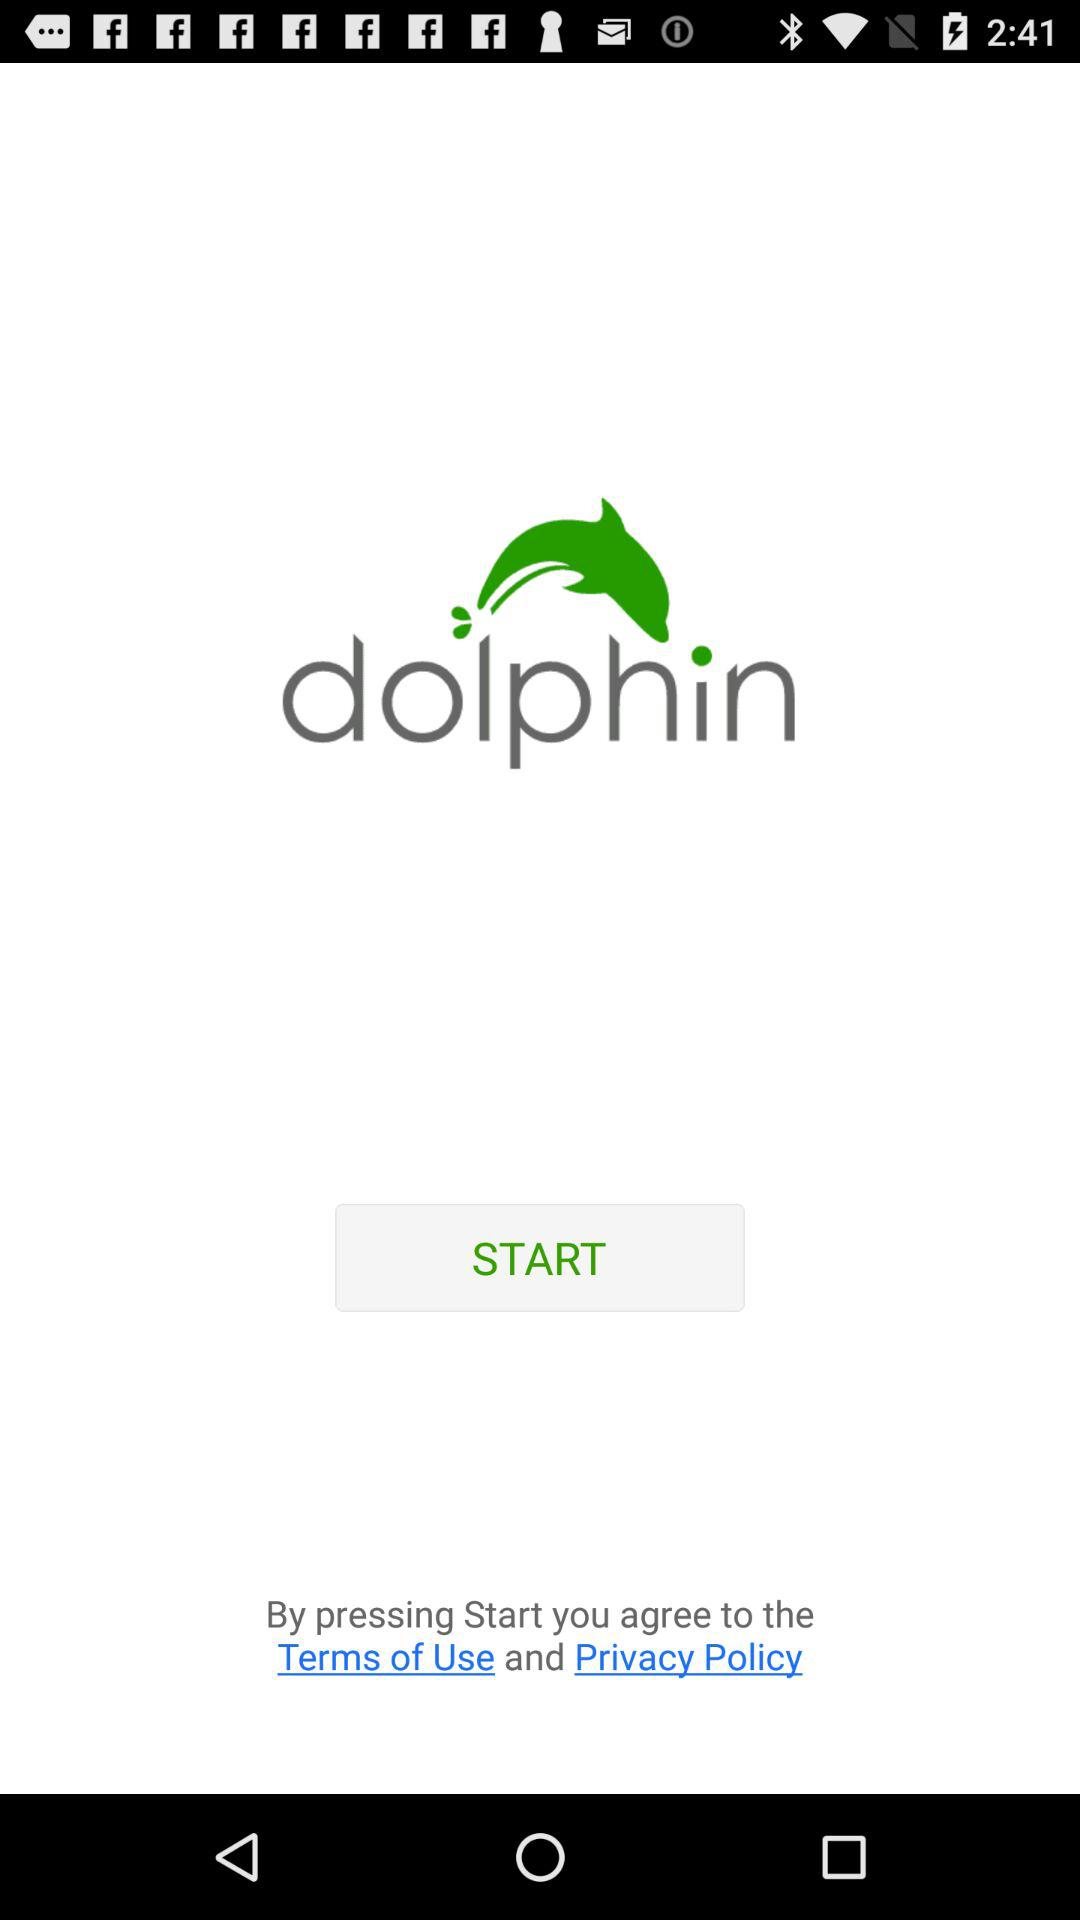What is the name of the application? The name of the application is "dolphin". 